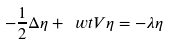Convert formula to latex. <formula><loc_0><loc_0><loc_500><loc_500>- \frac { 1 } { 2 } \Delta \eta + \ w t V \eta = - \lambda \eta</formula> 